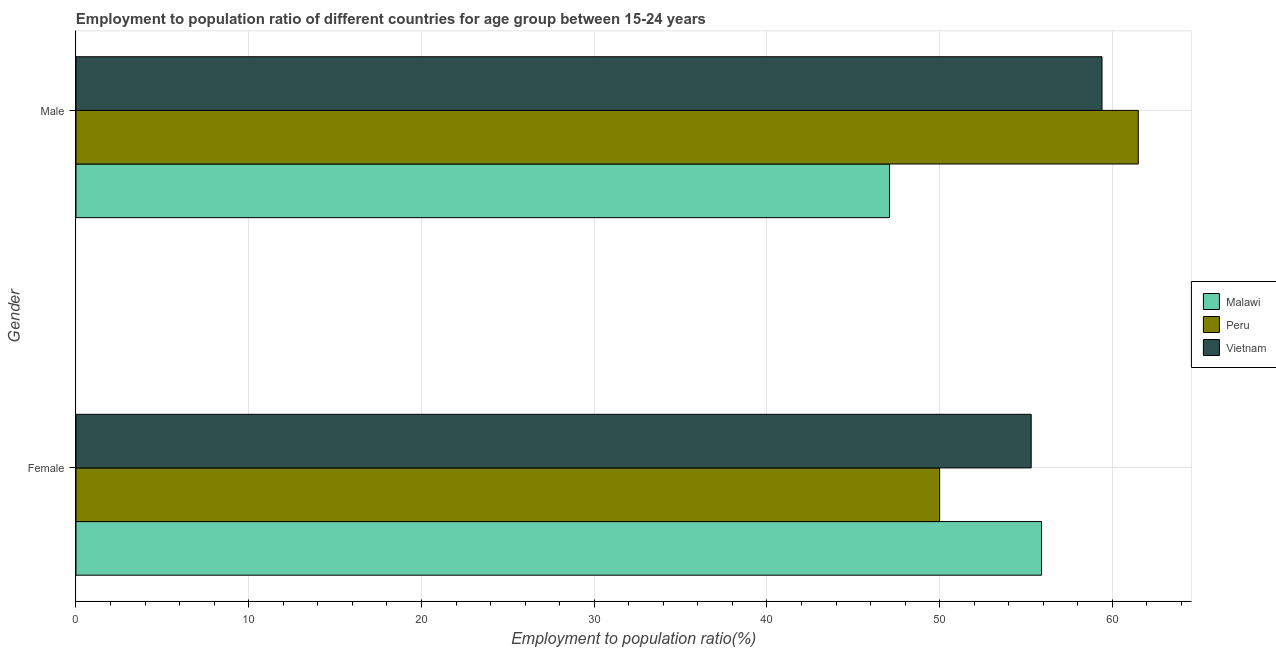How many groups of bars are there?
Offer a very short reply. 2. Are the number of bars per tick equal to the number of legend labels?
Give a very brief answer. Yes. Are the number of bars on each tick of the Y-axis equal?
Your answer should be very brief. Yes. What is the employment to population ratio(male) in Vietnam?
Keep it short and to the point. 59.4. Across all countries, what is the maximum employment to population ratio(female)?
Your response must be concise. 55.9. Across all countries, what is the minimum employment to population ratio(male)?
Ensure brevity in your answer.  47.1. In which country was the employment to population ratio(male) maximum?
Offer a very short reply. Peru. In which country was the employment to population ratio(female) minimum?
Your response must be concise. Peru. What is the total employment to population ratio(female) in the graph?
Make the answer very short. 161.2. What is the difference between the employment to population ratio(female) in Peru and that in Vietnam?
Offer a terse response. -5.3. What is the difference between the employment to population ratio(male) in Malawi and the employment to population ratio(female) in Peru?
Keep it short and to the point. -2.9. What is the average employment to population ratio(female) per country?
Make the answer very short. 53.73. What is the difference between the employment to population ratio(female) and employment to population ratio(male) in Malawi?
Keep it short and to the point. 8.8. In how many countries, is the employment to population ratio(male) greater than 46 %?
Your answer should be compact. 3. What is the ratio of the employment to population ratio(female) in Malawi to that in Vietnam?
Provide a short and direct response. 1.01. Is the employment to population ratio(male) in Malawi less than that in Peru?
Offer a very short reply. Yes. What does the 1st bar from the top in Female represents?
Make the answer very short. Vietnam. How many bars are there?
Your answer should be compact. 6. Are all the bars in the graph horizontal?
Ensure brevity in your answer.  Yes. How many countries are there in the graph?
Your answer should be compact. 3. What is the difference between two consecutive major ticks on the X-axis?
Ensure brevity in your answer.  10. Does the graph contain any zero values?
Give a very brief answer. No. Does the graph contain grids?
Keep it short and to the point. Yes. Where does the legend appear in the graph?
Your answer should be very brief. Center right. How are the legend labels stacked?
Your answer should be very brief. Vertical. What is the title of the graph?
Offer a terse response. Employment to population ratio of different countries for age group between 15-24 years. What is the label or title of the X-axis?
Ensure brevity in your answer.  Employment to population ratio(%). What is the label or title of the Y-axis?
Provide a succinct answer. Gender. What is the Employment to population ratio(%) of Malawi in Female?
Provide a short and direct response. 55.9. What is the Employment to population ratio(%) of Vietnam in Female?
Provide a short and direct response. 55.3. What is the Employment to population ratio(%) in Malawi in Male?
Provide a succinct answer. 47.1. What is the Employment to population ratio(%) in Peru in Male?
Keep it short and to the point. 61.5. What is the Employment to population ratio(%) of Vietnam in Male?
Make the answer very short. 59.4. Across all Gender, what is the maximum Employment to population ratio(%) in Malawi?
Ensure brevity in your answer.  55.9. Across all Gender, what is the maximum Employment to population ratio(%) in Peru?
Offer a terse response. 61.5. Across all Gender, what is the maximum Employment to population ratio(%) in Vietnam?
Provide a short and direct response. 59.4. Across all Gender, what is the minimum Employment to population ratio(%) in Malawi?
Provide a short and direct response. 47.1. Across all Gender, what is the minimum Employment to population ratio(%) in Vietnam?
Provide a succinct answer. 55.3. What is the total Employment to population ratio(%) of Malawi in the graph?
Your answer should be very brief. 103. What is the total Employment to population ratio(%) in Peru in the graph?
Your answer should be very brief. 111.5. What is the total Employment to population ratio(%) of Vietnam in the graph?
Provide a succinct answer. 114.7. What is the difference between the Employment to population ratio(%) of Malawi in Female and that in Male?
Keep it short and to the point. 8.8. What is the average Employment to population ratio(%) in Malawi per Gender?
Provide a succinct answer. 51.5. What is the average Employment to population ratio(%) of Peru per Gender?
Provide a short and direct response. 55.75. What is the average Employment to population ratio(%) of Vietnam per Gender?
Your response must be concise. 57.35. What is the difference between the Employment to population ratio(%) of Malawi and Employment to population ratio(%) of Peru in Female?
Your answer should be compact. 5.9. What is the difference between the Employment to population ratio(%) of Peru and Employment to population ratio(%) of Vietnam in Female?
Your answer should be very brief. -5.3. What is the difference between the Employment to population ratio(%) of Malawi and Employment to population ratio(%) of Peru in Male?
Ensure brevity in your answer.  -14.4. What is the difference between the Employment to population ratio(%) in Peru and Employment to population ratio(%) in Vietnam in Male?
Provide a short and direct response. 2.1. What is the ratio of the Employment to population ratio(%) in Malawi in Female to that in Male?
Provide a succinct answer. 1.19. What is the ratio of the Employment to population ratio(%) in Peru in Female to that in Male?
Your answer should be compact. 0.81. What is the ratio of the Employment to population ratio(%) of Vietnam in Female to that in Male?
Ensure brevity in your answer.  0.93. What is the difference between the highest and the second highest Employment to population ratio(%) of Malawi?
Ensure brevity in your answer.  8.8. What is the difference between the highest and the second highest Employment to population ratio(%) of Peru?
Give a very brief answer. 11.5. What is the difference between the highest and the lowest Employment to population ratio(%) in Malawi?
Provide a succinct answer. 8.8. 